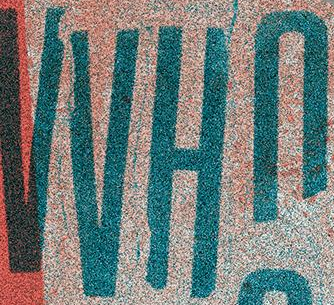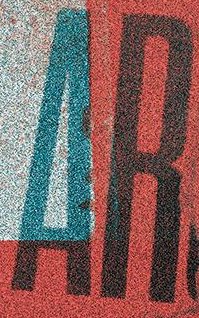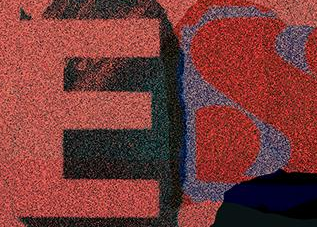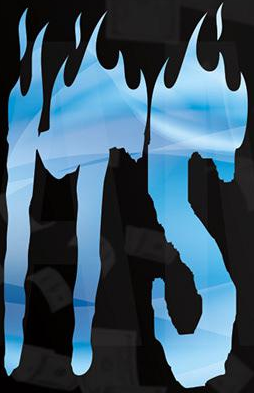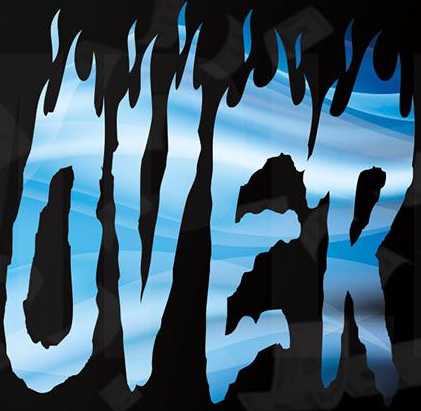What words can you see in these images in sequence, separated by a semicolon? VVHn; AR; ES; ITS; OVER 